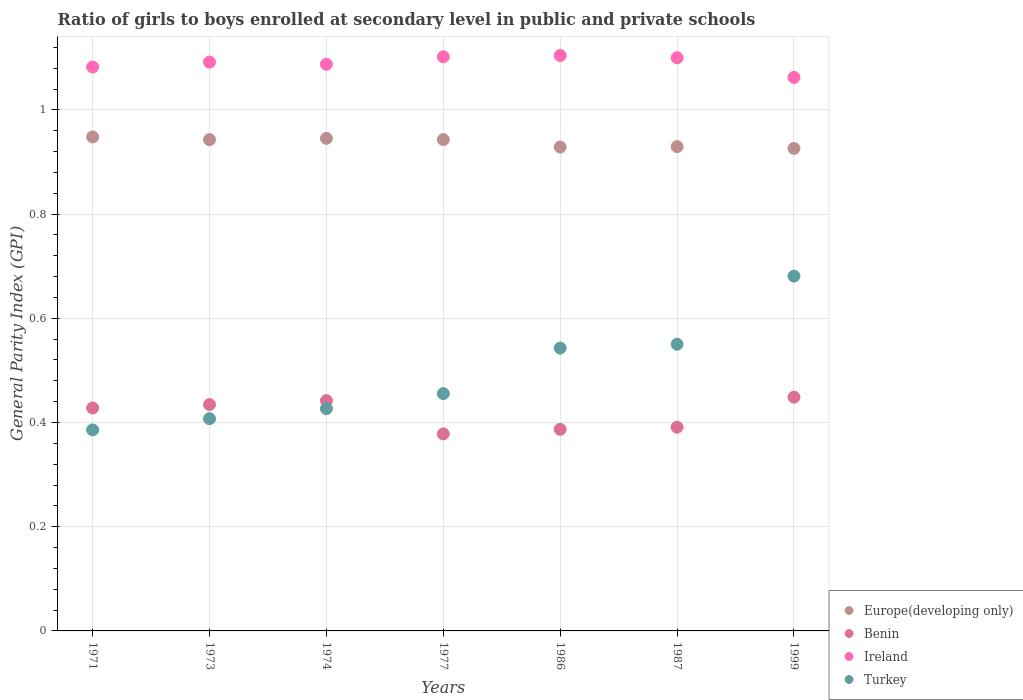How many different coloured dotlines are there?
Your response must be concise. 4. What is the general parity index in Ireland in 1986?
Offer a very short reply. 1.1. Across all years, what is the maximum general parity index in Ireland?
Offer a terse response. 1.1. Across all years, what is the minimum general parity index in Benin?
Ensure brevity in your answer.  0.38. In which year was the general parity index in Turkey minimum?
Your answer should be compact. 1971. What is the total general parity index in Turkey in the graph?
Your answer should be very brief. 3.45. What is the difference between the general parity index in Ireland in 1986 and that in 1999?
Provide a succinct answer. 0.04. What is the difference between the general parity index in Europe(developing only) in 1973 and the general parity index in Ireland in 1974?
Your answer should be compact. -0.14. What is the average general parity index in Benin per year?
Provide a short and direct response. 0.42. In the year 1999, what is the difference between the general parity index in Benin and general parity index in Ireland?
Make the answer very short. -0.61. What is the ratio of the general parity index in Ireland in 1977 to that in 1986?
Your answer should be compact. 1. Is the general parity index in Benin in 1971 less than that in 1973?
Your answer should be very brief. Yes. Is the difference between the general parity index in Benin in 1971 and 1986 greater than the difference between the general parity index in Ireland in 1971 and 1986?
Provide a short and direct response. Yes. What is the difference between the highest and the second highest general parity index in Turkey?
Your answer should be very brief. 0.13. What is the difference between the highest and the lowest general parity index in Europe(developing only)?
Ensure brevity in your answer.  0.02. In how many years, is the general parity index in Europe(developing only) greater than the average general parity index in Europe(developing only) taken over all years?
Your answer should be very brief. 4. Does the general parity index in Turkey monotonically increase over the years?
Give a very brief answer. Yes. Is the general parity index in Benin strictly greater than the general parity index in Ireland over the years?
Give a very brief answer. No. Is the general parity index in Turkey strictly less than the general parity index in Ireland over the years?
Give a very brief answer. Yes. How many dotlines are there?
Provide a short and direct response. 4. What is the difference between two consecutive major ticks on the Y-axis?
Offer a very short reply. 0.2. Does the graph contain grids?
Give a very brief answer. Yes. Where does the legend appear in the graph?
Your answer should be very brief. Bottom right. How many legend labels are there?
Ensure brevity in your answer.  4. What is the title of the graph?
Provide a succinct answer. Ratio of girls to boys enrolled at secondary level in public and private schools. Does "Greenland" appear as one of the legend labels in the graph?
Ensure brevity in your answer.  No. What is the label or title of the X-axis?
Provide a succinct answer. Years. What is the label or title of the Y-axis?
Your answer should be very brief. General Parity Index (GPI). What is the General Parity Index (GPI) of Europe(developing only) in 1971?
Your answer should be compact. 0.95. What is the General Parity Index (GPI) of Benin in 1971?
Make the answer very short. 0.43. What is the General Parity Index (GPI) in Ireland in 1971?
Your answer should be compact. 1.08. What is the General Parity Index (GPI) of Turkey in 1971?
Give a very brief answer. 0.39. What is the General Parity Index (GPI) of Europe(developing only) in 1973?
Provide a short and direct response. 0.94. What is the General Parity Index (GPI) in Benin in 1973?
Your response must be concise. 0.43. What is the General Parity Index (GPI) in Ireland in 1973?
Your response must be concise. 1.09. What is the General Parity Index (GPI) in Turkey in 1973?
Provide a short and direct response. 0.41. What is the General Parity Index (GPI) in Europe(developing only) in 1974?
Offer a terse response. 0.95. What is the General Parity Index (GPI) in Benin in 1974?
Provide a short and direct response. 0.44. What is the General Parity Index (GPI) in Ireland in 1974?
Provide a succinct answer. 1.09. What is the General Parity Index (GPI) in Turkey in 1974?
Keep it short and to the point. 0.43. What is the General Parity Index (GPI) in Europe(developing only) in 1977?
Provide a succinct answer. 0.94. What is the General Parity Index (GPI) in Benin in 1977?
Keep it short and to the point. 0.38. What is the General Parity Index (GPI) in Ireland in 1977?
Give a very brief answer. 1.1. What is the General Parity Index (GPI) of Turkey in 1977?
Provide a short and direct response. 0.46. What is the General Parity Index (GPI) of Europe(developing only) in 1986?
Make the answer very short. 0.93. What is the General Parity Index (GPI) of Benin in 1986?
Your answer should be compact. 0.39. What is the General Parity Index (GPI) of Ireland in 1986?
Keep it short and to the point. 1.1. What is the General Parity Index (GPI) in Turkey in 1986?
Provide a succinct answer. 0.54. What is the General Parity Index (GPI) of Europe(developing only) in 1987?
Provide a succinct answer. 0.93. What is the General Parity Index (GPI) in Benin in 1987?
Provide a succinct answer. 0.39. What is the General Parity Index (GPI) of Ireland in 1987?
Keep it short and to the point. 1.1. What is the General Parity Index (GPI) in Turkey in 1987?
Offer a terse response. 0.55. What is the General Parity Index (GPI) of Europe(developing only) in 1999?
Your answer should be compact. 0.93. What is the General Parity Index (GPI) in Benin in 1999?
Offer a very short reply. 0.45. What is the General Parity Index (GPI) in Ireland in 1999?
Provide a succinct answer. 1.06. What is the General Parity Index (GPI) in Turkey in 1999?
Offer a very short reply. 0.68. Across all years, what is the maximum General Parity Index (GPI) of Europe(developing only)?
Offer a terse response. 0.95. Across all years, what is the maximum General Parity Index (GPI) in Benin?
Offer a very short reply. 0.45. Across all years, what is the maximum General Parity Index (GPI) in Ireland?
Keep it short and to the point. 1.1. Across all years, what is the maximum General Parity Index (GPI) of Turkey?
Offer a very short reply. 0.68. Across all years, what is the minimum General Parity Index (GPI) of Europe(developing only)?
Your response must be concise. 0.93. Across all years, what is the minimum General Parity Index (GPI) of Benin?
Make the answer very short. 0.38. Across all years, what is the minimum General Parity Index (GPI) of Ireland?
Your response must be concise. 1.06. Across all years, what is the minimum General Parity Index (GPI) of Turkey?
Ensure brevity in your answer.  0.39. What is the total General Parity Index (GPI) in Europe(developing only) in the graph?
Keep it short and to the point. 6.56. What is the total General Parity Index (GPI) of Benin in the graph?
Make the answer very short. 2.91. What is the total General Parity Index (GPI) in Ireland in the graph?
Keep it short and to the point. 7.63. What is the total General Parity Index (GPI) of Turkey in the graph?
Ensure brevity in your answer.  3.45. What is the difference between the General Parity Index (GPI) in Europe(developing only) in 1971 and that in 1973?
Ensure brevity in your answer.  0.01. What is the difference between the General Parity Index (GPI) in Benin in 1971 and that in 1973?
Offer a terse response. -0.01. What is the difference between the General Parity Index (GPI) in Ireland in 1971 and that in 1973?
Your answer should be very brief. -0.01. What is the difference between the General Parity Index (GPI) in Turkey in 1971 and that in 1973?
Ensure brevity in your answer.  -0.02. What is the difference between the General Parity Index (GPI) of Europe(developing only) in 1971 and that in 1974?
Your response must be concise. 0. What is the difference between the General Parity Index (GPI) in Benin in 1971 and that in 1974?
Ensure brevity in your answer.  -0.01. What is the difference between the General Parity Index (GPI) of Ireland in 1971 and that in 1974?
Offer a terse response. -0.01. What is the difference between the General Parity Index (GPI) of Turkey in 1971 and that in 1974?
Ensure brevity in your answer.  -0.04. What is the difference between the General Parity Index (GPI) of Europe(developing only) in 1971 and that in 1977?
Offer a very short reply. 0.01. What is the difference between the General Parity Index (GPI) in Benin in 1971 and that in 1977?
Your answer should be very brief. 0.05. What is the difference between the General Parity Index (GPI) of Ireland in 1971 and that in 1977?
Ensure brevity in your answer.  -0.02. What is the difference between the General Parity Index (GPI) in Turkey in 1971 and that in 1977?
Provide a succinct answer. -0.07. What is the difference between the General Parity Index (GPI) of Europe(developing only) in 1971 and that in 1986?
Offer a terse response. 0.02. What is the difference between the General Parity Index (GPI) in Benin in 1971 and that in 1986?
Provide a short and direct response. 0.04. What is the difference between the General Parity Index (GPI) of Ireland in 1971 and that in 1986?
Provide a succinct answer. -0.02. What is the difference between the General Parity Index (GPI) in Turkey in 1971 and that in 1986?
Keep it short and to the point. -0.16. What is the difference between the General Parity Index (GPI) in Europe(developing only) in 1971 and that in 1987?
Your response must be concise. 0.02. What is the difference between the General Parity Index (GPI) of Benin in 1971 and that in 1987?
Give a very brief answer. 0.04. What is the difference between the General Parity Index (GPI) of Ireland in 1971 and that in 1987?
Make the answer very short. -0.02. What is the difference between the General Parity Index (GPI) of Turkey in 1971 and that in 1987?
Your response must be concise. -0.16. What is the difference between the General Parity Index (GPI) in Europe(developing only) in 1971 and that in 1999?
Your answer should be very brief. 0.02. What is the difference between the General Parity Index (GPI) of Benin in 1971 and that in 1999?
Offer a terse response. -0.02. What is the difference between the General Parity Index (GPI) in Ireland in 1971 and that in 1999?
Your answer should be very brief. 0.02. What is the difference between the General Parity Index (GPI) of Turkey in 1971 and that in 1999?
Your response must be concise. -0.3. What is the difference between the General Parity Index (GPI) in Europe(developing only) in 1973 and that in 1974?
Your response must be concise. -0. What is the difference between the General Parity Index (GPI) of Benin in 1973 and that in 1974?
Offer a terse response. -0.01. What is the difference between the General Parity Index (GPI) in Ireland in 1973 and that in 1974?
Provide a succinct answer. 0. What is the difference between the General Parity Index (GPI) in Turkey in 1973 and that in 1974?
Ensure brevity in your answer.  -0.02. What is the difference between the General Parity Index (GPI) in Europe(developing only) in 1973 and that in 1977?
Give a very brief answer. -0. What is the difference between the General Parity Index (GPI) in Benin in 1973 and that in 1977?
Provide a succinct answer. 0.06. What is the difference between the General Parity Index (GPI) in Ireland in 1973 and that in 1977?
Provide a succinct answer. -0.01. What is the difference between the General Parity Index (GPI) of Turkey in 1973 and that in 1977?
Offer a terse response. -0.05. What is the difference between the General Parity Index (GPI) of Europe(developing only) in 1973 and that in 1986?
Your answer should be compact. 0.01. What is the difference between the General Parity Index (GPI) of Benin in 1973 and that in 1986?
Your answer should be compact. 0.05. What is the difference between the General Parity Index (GPI) in Ireland in 1973 and that in 1986?
Your response must be concise. -0.01. What is the difference between the General Parity Index (GPI) in Turkey in 1973 and that in 1986?
Your response must be concise. -0.14. What is the difference between the General Parity Index (GPI) of Europe(developing only) in 1973 and that in 1987?
Ensure brevity in your answer.  0.01. What is the difference between the General Parity Index (GPI) of Benin in 1973 and that in 1987?
Make the answer very short. 0.04. What is the difference between the General Parity Index (GPI) of Ireland in 1973 and that in 1987?
Provide a short and direct response. -0.01. What is the difference between the General Parity Index (GPI) of Turkey in 1973 and that in 1987?
Offer a terse response. -0.14. What is the difference between the General Parity Index (GPI) of Europe(developing only) in 1973 and that in 1999?
Offer a terse response. 0.02. What is the difference between the General Parity Index (GPI) of Benin in 1973 and that in 1999?
Make the answer very short. -0.01. What is the difference between the General Parity Index (GPI) of Ireland in 1973 and that in 1999?
Make the answer very short. 0.03. What is the difference between the General Parity Index (GPI) in Turkey in 1973 and that in 1999?
Ensure brevity in your answer.  -0.27. What is the difference between the General Parity Index (GPI) of Europe(developing only) in 1974 and that in 1977?
Provide a short and direct response. 0. What is the difference between the General Parity Index (GPI) of Benin in 1974 and that in 1977?
Make the answer very short. 0.06. What is the difference between the General Parity Index (GPI) in Ireland in 1974 and that in 1977?
Offer a terse response. -0.01. What is the difference between the General Parity Index (GPI) in Turkey in 1974 and that in 1977?
Your answer should be compact. -0.03. What is the difference between the General Parity Index (GPI) in Europe(developing only) in 1974 and that in 1986?
Your answer should be compact. 0.02. What is the difference between the General Parity Index (GPI) of Benin in 1974 and that in 1986?
Your answer should be compact. 0.06. What is the difference between the General Parity Index (GPI) in Ireland in 1974 and that in 1986?
Your response must be concise. -0.02. What is the difference between the General Parity Index (GPI) of Turkey in 1974 and that in 1986?
Make the answer very short. -0.12. What is the difference between the General Parity Index (GPI) of Europe(developing only) in 1974 and that in 1987?
Your answer should be compact. 0.02. What is the difference between the General Parity Index (GPI) of Benin in 1974 and that in 1987?
Ensure brevity in your answer.  0.05. What is the difference between the General Parity Index (GPI) of Ireland in 1974 and that in 1987?
Ensure brevity in your answer.  -0.01. What is the difference between the General Parity Index (GPI) in Turkey in 1974 and that in 1987?
Offer a very short reply. -0.12. What is the difference between the General Parity Index (GPI) in Europe(developing only) in 1974 and that in 1999?
Offer a very short reply. 0.02. What is the difference between the General Parity Index (GPI) in Benin in 1974 and that in 1999?
Your answer should be compact. -0.01. What is the difference between the General Parity Index (GPI) in Ireland in 1974 and that in 1999?
Provide a succinct answer. 0.03. What is the difference between the General Parity Index (GPI) in Turkey in 1974 and that in 1999?
Provide a short and direct response. -0.25. What is the difference between the General Parity Index (GPI) in Europe(developing only) in 1977 and that in 1986?
Offer a terse response. 0.01. What is the difference between the General Parity Index (GPI) in Benin in 1977 and that in 1986?
Offer a very short reply. -0.01. What is the difference between the General Parity Index (GPI) in Ireland in 1977 and that in 1986?
Provide a succinct answer. -0. What is the difference between the General Parity Index (GPI) in Turkey in 1977 and that in 1986?
Keep it short and to the point. -0.09. What is the difference between the General Parity Index (GPI) of Europe(developing only) in 1977 and that in 1987?
Your response must be concise. 0.01. What is the difference between the General Parity Index (GPI) in Benin in 1977 and that in 1987?
Your response must be concise. -0.01. What is the difference between the General Parity Index (GPI) of Ireland in 1977 and that in 1987?
Your answer should be very brief. 0. What is the difference between the General Parity Index (GPI) of Turkey in 1977 and that in 1987?
Your answer should be compact. -0.09. What is the difference between the General Parity Index (GPI) of Europe(developing only) in 1977 and that in 1999?
Your answer should be compact. 0.02. What is the difference between the General Parity Index (GPI) of Benin in 1977 and that in 1999?
Ensure brevity in your answer.  -0.07. What is the difference between the General Parity Index (GPI) of Ireland in 1977 and that in 1999?
Keep it short and to the point. 0.04. What is the difference between the General Parity Index (GPI) of Turkey in 1977 and that in 1999?
Make the answer very short. -0.23. What is the difference between the General Parity Index (GPI) in Europe(developing only) in 1986 and that in 1987?
Provide a short and direct response. -0. What is the difference between the General Parity Index (GPI) in Benin in 1986 and that in 1987?
Offer a terse response. -0. What is the difference between the General Parity Index (GPI) of Ireland in 1986 and that in 1987?
Offer a terse response. 0. What is the difference between the General Parity Index (GPI) of Turkey in 1986 and that in 1987?
Give a very brief answer. -0.01. What is the difference between the General Parity Index (GPI) in Europe(developing only) in 1986 and that in 1999?
Provide a short and direct response. 0. What is the difference between the General Parity Index (GPI) in Benin in 1986 and that in 1999?
Make the answer very short. -0.06. What is the difference between the General Parity Index (GPI) of Ireland in 1986 and that in 1999?
Your response must be concise. 0.04. What is the difference between the General Parity Index (GPI) of Turkey in 1986 and that in 1999?
Ensure brevity in your answer.  -0.14. What is the difference between the General Parity Index (GPI) in Europe(developing only) in 1987 and that in 1999?
Make the answer very short. 0. What is the difference between the General Parity Index (GPI) of Benin in 1987 and that in 1999?
Keep it short and to the point. -0.06. What is the difference between the General Parity Index (GPI) of Ireland in 1987 and that in 1999?
Offer a very short reply. 0.04. What is the difference between the General Parity Index (GPI) of Turkey in 1987 and that in 1999?
Ensure brevity in your answer.  -0.13. What is the difference between the General Parity Index (GPI) in Europe(developing only) in 1971 and the General Parity Index (GPI) in Benin in 1973?
Your answer should be compact. 0.51. What is the difference between the General Parity Index (GPI) in Europe(developing only) in 1971 and the General Parity Index (GPI) in Ireland in 1973?
Ensure brevity in your answer.  -0.14. What is the difference between the General Parity Index (GPI) of Europe(developing only) in 1971 and the General Parity Index (GPI) of Turkey in 1973?
Your response must be concise. 0.54. What is the difference between the General Parity Index (GPI) in Benin in 1971 and the General Parity Index (GPI) in Ireland in 1973?
Offer a very short reply. -0.66. What is the difference between the General Parity Index (GPI) in Benin in 1971 and the General Parity Index (GPI) in Turkey in 1973?
Your answer should be compact. 0.02. What is the difference between the General Parity Index (GPI) in Ireland in 1971 and the General Parity Index (GPI) in Turkey in 1973?
Offer a terse response. 0.67. What is the difference between the General Parity Index (GPI) of Europe(developing only) in 1971 and the General Parity Index (GPI) of Benin in 1974?
Give a very brief answer. 0.51. What is the difference between the General Parity Index (GPI) of Europe(developing only) in 1971 and the General Parity Index (GPI) of Ireland in 1974?
Keep it short and to the point. -0.14. What is the difference between the General Parity Index (GPI) in Europe(developing only) in 1971 and the General Parity Index (GPI) in Turkey in 1974?
Provide a succinct answer. 0.52. What is the difference between the General Parity Index (GPI) of Benin in 1971 and the General Parity Index (GPI) of Ireland in 1974?
Ensure brevity in your answer.  -0.66. What is the difference between the General Parity Index (GPI) of Benin in 1971 and the General Parity Index (GPI) of Turkey in 1974?
Your answer should be compact. 0. What is the difference between the General Parity Index (GPI) of Ireland in 1971 and the General Parity Index (GPI) of Turkey in 1974?
Offer a terse response. 0.66. What is the difference between the General Parity Index (GPI) in Europe(developing only) in 1971 and the General Parity Index (GPI) in Benin in 1977?
Give a very brief answer. 0.57. What is the difference between the General Parity Index (GPI) in Europe(developing only) in 1971 and the General Parity Index (GPI) in Ireland in 1977?
Provide a succinct answer. -0.15. What is the difference between the General Parity Index (GPI) of Europe(developing only) in 1971 and the General Parity Index (GPI) of Turkey in 1977?
Provide a short and direct response. 0.49. What is the difference between the General Parity Index (GPI) of Benin in 1971 and the General Parity Index (GPI) of Ireland in 1977?
Your answer should be compact. -0.67. What is the difference between the General Parity Index (GPI) of Benin in 1971 and the General Parity Index (GPI) of Turkey in 1977?
Provide a short and direct response. -0.03. What is the difference between the General Parity Index (GPI) of Ireland in 1971 and the General Parity Index (GPI) of Turkey in 1977?
Provide a short and direct response. 0.63. What is the difference between the General Parity Index (GPI) in Europe(developing only) in 1971 and the General Parity Index (GPI) in Benin in 1986?
Provide a succinct answer. 0.56. What is the difference between the General Parity Index (GPI) of Europe(developing only) in 1971 and the General Parity Index (GPI) of Ireland in 1986?
Keep it short and to the point. -0.16. What is the difference between the General Parity Index (GPI) in Europe(developing only) in 1971 and the General Parity Index (GPI) in Turkey in 1986?
Provide a short and direct response. 0.41. What is the difference between the General Parity Index (GPI) of Benin in 1971 and the General Parity Index (GPI) of Ireland in 1986?
Make the answer very short. -0.68. What is the difference between the General Parity Index (GPI) of Benin in 1971 and the General Parity Index (GPI) of Turkey in 1986?
Provide a succinct answer. -0.11. What is the difference between the General Parity Index (GPI) in Ireland in 1971 and the General Parity Index (GPI) in Turkey in 1986?
Ensure brevity in your answer.  0.54. What is the difference between the General Parity Index (GPI) of Europe(developing only) in 1971 and the General Parity Index (GPI) of Benin in 1987?
Provide a short and direct response. 0.56. What is the difference between the General Parity Index (GPI) of Europe(developing only) in 1971 and the General Parity Index (GPI) of Ireland in 1987?
Provide a short and direct response. -0.15. What is the difference between the General Parity Index (GPI) of Europe(developing only) in 1971 and the General Parity Index (GPI) of Turkey in 1987?
Give a very brief answer. 0.4. What is the difference between the General Parity Index (GPI) of Benin in 1971 and the General Parity Index (GPI) of Ireland in 1987?
Your response must be concise. -0.67. What is the difference between the General Parity Index (GPI) in Benin in 1971 and the General Parity Index (GPI) in Turkey in 1987?
Ensure brevity in your answer.  -0.12. What is the difference between the General Parity Index (GPI) in Ireland in 1971 and the General Parity Index (GPI) in Turkey in 1987?
Ensure brevity in your answer.  0.53. What is the difference between the General Parity Index (GPI) in Europe(developing only) in 1971 and the General Parity Index (GPI) in Benin in 1999?
Offer a very short reply. 0.5. What is the difference between the General Parity Index (GPI) in Europe(developing only) in 1971 and the General Parity Index (GPI) in Ireland in 1999?
Offer a very short reply. -0.11. What is the difference between the General Parity Index (GPI) of Europe(developing only) in 1971 and the General Parity Index (GPI) of Turkey in 1999?
Give a very brief answer. 0.27. What is the difference between the General Parity Index (GPI) of Benin in 1971 and the General Parity Index (GPI) of Ireland in 1999?
Ensure brevity in your answer.  -0.63. What is the difference between the General Parity Index (GPI) in Benin in 1971 and the General Parity Index (GPI) in Turkey in 1999?
Your response must be concise. -0.25. What is the difference between the General Parity Index (GPI) of Ireland in 1971 and the General Parity Index (GPI) of Turkey in 1999?
Keep it short and to the point. 0.4. What is the difference between the General Parity Index (GPI) of Europe(developing only) in 1973 and the General Parity Index (GPI) of Benin in 1974?
Your response must be concise. 0.5. What is the difference between the General Parity Index (GPI) in Europe(developing only) in 1973 and the General Parity Index (GPI) in Ireland in 1974?
Ensure brevity in your answer.  -0.14. What is the difference between the General Parity Index (GPI) in Europe(developing only) in 1973 and the General Parity Index (GPI) in Turkey in 1974?
Your answer should be compact. 0.52. What is the difference between the General Parity Index (GPI) of Benin in 1973 and the General Parity Index (GPI) of Ireland in 1974?
Provide a short and direct response. -0.65. What is the difference between the General Parity Index (GPI) in Benin in 1973 and the General Parity Index (GPI) in Turkey in 1974?
Offer a very short reply. 0.01. What is the difference between the General Parity Index (GPI) of Ireland in 1973 and the General Parity Index (GPI) of Turkey in 1974?
Your response must be concise. 0.67. What is the difference between the General Parity Index (GPI) in Europe(developing only) in 1973 and the General Parity Index (GPI) in Benin in 1977?
Ensure brevity in your answer.  0.56. What is the difference between the General Parity Index (GPI) of Europe(developing only) in 1973 and the General Parity Index (GPI) of Ireland in 1977?
Offer a terse response. -0.16. What is the difference between the General Parity Index (GPI) of Europe(developing only) in 1973 and the General Parity Index (GPI) of Turkey in 1977?
Give a very brief answer. 0.49. What is the difference between the General Parity Index (GPI) of Benin in 1973 and the General Parity Index (GPI) of Ireland in 1977?
Keep it short and to the point. -0.67. What is the difference between the General Parity Index (GPI) of Benin in 1973 and the General Parity Index (GPI) of Turkey in 1977?
Your response must be concise. -0.02. What is the difference between the General Parity Index (GPI) in Ireland in 1973 and the General Parity Index (GPI) in Turkey in 1977?
Give a very brief answer. 0.64. What is the difference between the General Parity Index (GPI) in Europe(developing only) in 1973 and the General Parity Index (GPI) in Benin in 1986?
Ensure brevity in your answer.  0.56. What is the difference between the General Parity Index (GPI) of Europe(developing only) in 1973 and the General Parity Index (GPI) of Ireland in 1986?
Your answer should be compact. -0.16. What is the difference between the General Parity Index (GPI) in Europe(developing only) in 1973 and the General Parity Index (GPI) in Turkey in 1986?
Keep it short and to the point. 0.4. What is the difference between the General Parity Index (GPI) in Benin in 1973 and the General Parity Index (GPI) in Ireland in 1986?
Offer a terse response. -0.67. What is the difference between the General Parity Index (GPI) of Benin in 1973 and the General Parity Index (GPI) of Turkey in 1986?
Ensure brevity in your answer.  -0.11. What is the difference between the General Parity Index (GPI) of Ireland in 1973 and the General Parity Index (GPI) of Turkey in 1986?
Make the answer very short. 0.55. What is the difference between the General Parity Index (GPI) of Europe(developing only) in 1973 and the General Parity Index (GPI) of Benin in 1987?
Keep it short and to the point. 0.55. What is the difference between the General Parity Index (GPI) in Europe(developing only) in 1973 and the General Parity Index (GPI) in Ireland in 1987?
Offer a terse response. -0.16. What is the difference between the General Parity Index (GPI) in Europe(developing only) in 1973 and the General Parity Index (GPI) in Turkey in 1987?
Ensure brevity in your answer.  0.39. What is the difference between the General Parity Index (GPI) of Benin in 1973 and the General Parity Index (GPI) of Ireland in 1987?
Provide a short and direct response. -0.67. What is the difference between the General Parity Index (GPI) of Benin in 1973 and the General Parity Index (GPI) of Turkey in 1987?
Provide a short and direct response. -0.12. What is the difference between the General Parity Index (GPI) in Ireland in 1973 and the General Parity Index (GPI) in Turkey in 1987?
Provide a short and direct response. 0.54. What is the difference between the General Parity Index (GPI) in Europe(developing only) in 1973 and the General Parity Index (GPI) in Benin in 1999?
Your response must be concise. 0.49. What is the difference between the General Parity Index (GPI) in Europe(developing only) in 1973 and the General Parity Index (GPI) in Ireland in 1999?
Your response must be concise. -0.12. What is the difference between the General Parity Index (GPI) in Europe(developing only) in 1973 and the General Parity Index (GPI) in Turkey in 1999?
Make the answer very short. 0.26. What is the difference between the General Parity Index (GPI) in Benin in 1973 and the General Parity Index (GPI) in Ireland in 1999?
Your response must be concise. -0.63. What is the difference between the General Parity Index (GPI) of Benin in 1973 and the General Parity Index (GPI) of Turkey in 1999?
Your answer should be very brief. -0.25. What is the difference between the General Parity Index (GPI) in Ireland in 1973 and the General Parity Index (GPI) in Turkey in 1999?
Offer a terse response. 0.41. What is the difference between the General Parity Index (GPI) of Europe(developing only) in 1974 and the General Parity Index (GPI) of Benin in 1977?
Offer a very short reply. 0.57. What is the difference between the General Parity Index (GPI) of Europe(developing only) in 1974 and the General Parity Index (GPI) of Ireland in 1977?
Provide a short and direct response. -0.16. What is the difference between the General Parity Index (GPI) in Europe(developing only) in 1974 and the General Parity Index (GPI) in Turkey in 1977?
Give a very brief answer. 0.49. What is the difference between the General Parity Index (GPI) of Benin in 1974 and the General Parity Index (GPI) of Ireland in 1977?
Provide a succinct answer. -0.66. What is the difference between the General Parity Index (GPI) of Benin in 1974 and the General Parity Index (GPI) of Turkey in 1977?
Ensure brevity in your answer.  -0.01. What is the difference between the General Parity Index (GPI) of Ireland in 1974 and the General Parity Index (GPI) of Turkey in 1977?
Offer a very short reply. 0.63. What is the difference between the General Parity Index (GPI) of Europe(developing only) in 1974 and the General Parity Index (GPI) of Benin in 1986?
Offer a terse response. 0.56. What is the difference between the General Parity Index (GPI) in Europe(developing only) in 1974 and the General Parity Index (GPI) in Ireland in 1986?
Ensure brevity in your answer.  -0.16. What is the difference between the General Parity Index (GPI) in Europe(developing only) in 1974 and the General Parity Index (GPI) in Turkey in 1986?
Provide a succinct answer. 0.4. What is the difference between the General Parity Index (GPI) of Benin in 1974 and the General Parity Index (GPI) of Ireland in 1986?
Provide a succinct answer. -0.66. What is the difference between the General Parity Index (GPI) of Benin in 1974 and the General Parity Index (GPI) of Turkey in 1986?
Ensure brevity in your answer.  -0.1. What is the difference between the General Parity Index (GPI) of Ireland in 1974 and the General Parity Index (GPI) of Turkey in 1986?
Make the answer very short. 0.54. What is the difference between the General Parity Index (GPI) of Europe(developing only) in 1974 and the General Parity Index (GPI) of Benin in 1987?
Your answer should be compact. 0.55. What is the difference between the General Parity Index (GPI) in Europe(developing only) in 1974 and the General Parity Index (GPI) in Ireland in 1987?
Give a very brief answer. -0.15. What is the difference between the General Parity Index (GPI) in Europe(developing only) in 1974 and the General Parity Index (GPI) in Turkey in 1987?
Provide a short and direct response. 0.4. What is the difference between the General Parity Index (GPI) in Benin in 1974 and the General Parity Index (GPI) in Ireland in 1987?
Your answer should be very brief. -0.66. What is the difference between the General Parity Index (GPI) of Benin in 1974 and the General Parity Index (GPI) of Turkey in 1987?
Give a very brief answer. -0.11. What is the difference between the General Parity Index (GPI) of Ireland in 1974 and the General Parity Index (GPI) of Turkey in 1987?
Your response must be concise. 0.54. What is the difference between the General Parity Index (GPI) in Europe(developing only) in 1974 and the General Parity Index (GPI) in Benin in 1999?
Make the answer very short. 0.5. What is the difference between the General Parity Index (GPI) in Europe(developing only) in 1974 and the General Parity Index (GPI) in Ireland in 1999?
Your answer should be compact. -0.12. What is the difference between the General Parity Index (GPI) of Europe(developing only) in 1974 and the General Parity Index (GPI) of Turkey in 1999?
Your answer should be very brief. 0.26. What is the difference between the General Parity Index (GPI) in Benin in 1974 and the General Parity Index (GPI) in Ireland in 1999?
Offer a terse response. -0.62. What is the difference between the General Parity Index (GPI) of Benin in 1974 and the General Parity Index (GPI) of Turkey in 1999?
Keep it short and to the point. -0.24. What is the difference between the General Parity Index (GPI) in Ireland in 1974 and the General Parity Index (GPI) in Turkey in 1999?
Provide a short and direct response. 0.41. What is the difference between the General Parity Index (GPI) of Europe(developing only) in 1977 and the General Parity Index (GPI) of Benin in 1986?
Provide a succinct answer. 0.56. What is the difference between the General Parity Index (GPI) of Europe(developing only) in 1977 and the General Parity Index (GPI) of Ireland in 1986?
Your answer should be compact. -0.16. What is the difference between the General Parity Index (GPI) of Europe(developing only) in 1977 and the General Parity Index (GPI) of Turkey in 1986?
Your response must be concise. 0.4. What is the difference between the General Parity Index (GPI) of Benin in 1977 and the General Parity Index (GPI) of Ireland in 1986?
Provide a succinct answer. -0.73. What is the difference between the General Parity Index (GPI) in Benin in 1977 and the General Parity Index (GPI) in Turkey in 1986?
Your answer should be very brief. -0.16. What is the difference between the General Parity Index (GPI) of Ireland in 1977 and the General Parity Index (GPI) of Turkey in 1986?
Your answer should be compact. 0.56. What is the difference between the General Parity Index (GPI) in Europe(developing only) in 1977 and the General Parity Index (GPI) in Benin in 1987?
Your response must be concise. 0.55. What is the difference between the General Parity Index (GPI) of Europe(developing only) in 1977 and the General Parity Index (GPI) of Ireland in 1987?
Offer a very short reply. -0.16. What is the difference between the General Parity Index (GPI) in Europe(developing only) in 1977 and the General Parity Index (GPI) in Turkey in 1987?
Your answer should be compact. 0.39. What is the difference between the General Parity Index (GPI) of Benin in 1977 and the General Parity Index (GPI) of Ireland in 1987?
Offer a terse response. -0.72. What is the difference between the General Parity Index (GPI) of Benin in 1977 and the General Parity Index (GPI) of Turkey in 1987?
Make the answer very short. -0.17. What is the difference between the General Parity Index (GPI) in Ireland in 1977 and the General Parity Index (GPI) in Turkey in 1987?
Offer a very short reply. 0.55. What is the difference between the General Parity Index (GPI) of Europe(developing only) in 1977 and the General Parity Index (GPI) of Benin in 1999?
Your answer should be compact. 0.49. What is the difference between the General Parity Index (GPI) in Europe(developing only) in 1977 and the General Parity Index (GPI) in Ireland in 1999?
Your answer should be compact. -0.12. What is the difference between the General Parity Index (GPI) of Europe(developing only) in 1977 and the General Parity Index (GPI) of Turkey in 1999?
Your answer should be compact. 0.26. What is the difference between the General Parity Index (GPI) in Benin in 1977 and the General Parity Index (GPI) in Ireland in 1999?
Your answer should be compact. -0.68. What is the difference between the General Parity Index (GPI) of Benin in 1977 and the General Parity Index (GPI) of Turkey in 1999?
Offer a very short reply. -0.3. What is the difference between the General Parity Index (GPI) in Ireland in 1977 and the General Parity Index (GPI) in Turkey in 1999?
Offer a very short reply. 0.42. What is the difference between the General Parity Index (GPI) in Europe(developing only) in 1986 and the General Parity Index (GPI) in Benin in 1987?
Your response must be concise. 0.54. What is the difference between the General Parity Index (GPI) in Europe(developing only) in 1986 and the General Parity Index (GPI) in Ireland in 1987?
Give a very brief answer. -0.17. What is the difference between the General Parity Index (GPI) of Europe(developing only) in 1986 and the General Parity Index (GPI) of Turkey in 1987?
Offer a terse response. 0.38. What is the difference between the General Parity Index (GPI) of Benin in 1986 and the General Parity Index (GPI) of Ireland in 1987?
Offer a very short reply. -0.71. What is the difference between the General Parity Index (GPI) in Benin in 1986 and the General Parity Index (GPI) in Turkey in 1987?
Offer a very short reply. -0.16. What is the difference between the General Parity Index (GPI) in Ireland in 1986 and the General Parity Index (GPI) in Turkey in 1987?
Your answer should be very brief. 0.55. What is the difference between the General Parity Index (GPI) of Europe(developing only) in 1986 and the General Parity Index (GPI) of Benin in 1999?
Provide a short and direct response. 0.48. What is the difference between the General Parity Index (GPI) in Europe(developing only) in 1986 and the General Parity Index (GPI) in Ireland in 1999?
Your response must be concise. -0.13. What is the difference between the General Parity Index (GPI) in Europe(developing only) in 1986 and the General Parity Index (GPI) in Turkey in 1999?
Your answer should be very brief. 0.25. What is the difference between the General Parity Index (GPI) of Benin in 1986 and the General Parity Index (GPI) of Ireland in 1999?
Your answer should be compact. -0.68. What is the difference between the General Parity Index (GPI) in Benin in 1986 and the General Parity Index (GPI) in Turkey in 1999?
Give a very brief answer. -0.29. What is the difference between the General Parity Index (GPI) in Ireland in 1986 and the General Parity Index (GPI) in Turkey in 1999?
Provide a succinct answer. 0.42. What is the difference between the General Parity Index (GPI) in Europe(developing only) in 1987 and the General Parity Index (GPI) in Benin in 1999?
Offer a terse response. 0.48. What is the difference between the General Parity Index (GPI) of Europe(developing only) in 1987 and the General Parity Index (GPI) of Ireland in 1999?
Ensure brevity in your answer.  -0.13. What is the difference between the General Parity Index (GPI) of Europe(developing only) in 1987 and the General Parity Index (GPI) of Turkey in 1999?
Your answer should be compact. 0.25. What is the difference between the General Parity Index (GPI) in Benin in 1987 and the General Parity Index (GPI) in Ireland in 1999?
Keep it short and to the point. -0.67. What is the difference between the General Parity Index (GPI) of Benin in 1987 and the General Parity Index (GPI) of Turkey in 1999?
Your response must be concise. -0.29. What is the difference between the General Parity Index (GPI) of Ireland in 1987 and the General Parity Index (GPI) of Turkey in 1999?
Give a very brief answer. 0.42. What is the average General Parity Index (GPI) of Europe(developing only) per year?
Make the answer very short. 0.94. What is the average General Parity Index (GPI) of Benin per year?
Offer a terse response. 0.42. What is the average General Parity Index (GPI) in Ireland per year?
Provide a short and direct response. 1.09. What is the average General Parity Index (GPI) of Turkey per year?
Offer a very short reply. 0.49. In the year 1971, what is the difference between the General Parity Index (GPI) in Europe(developing only) and General Parity Index (GPI) in Benin?
Your answer should be compact. 0.52. In the year 1971, what is the difference between the General Parity Index (GPI) of Europe(developing only) and General Parity Index (GPI) of Ireland?
Provide a succinct answer. -0.13. In the year 1971, what is the difference between the General Parity Index (GPI) of Europe(developing only) and General Parity Index (GPI) of Turkey?
Provide a succinct answer. 0.56. In the year 1971, what is the difference between the General Parity Index (GPI) in Benin and General Parity Index (GPI) in Ireland?
Your answer should be very brief. -0.65. In the year 1971, what is the difference between the General Parity Index (GPI) of Benin and General Parity Index (GPI) of Turkey?
Ensure brevity in your answer.  0.04. In the year 1971, what is the difference between the General Parity Index (GPI) in Ireland and General Parity Index (GPI) in Turkey?
Offer a terse response. 0.7. In the year 1973, what is the difference between the General Parity Index (GPI) of Europe(developing only) and General Parity Index (GPI) of Benin?
Your answer should be compact. 0.51. In the year 1973, what is the difference between the General Parity Index (GPI) of Europe(developing only) and General Parity Index (GPI) of Ireland?
Give a very brief answer. -0.15. In the year 1973, what is the difference between the General Parity Index (GPI) of Europe(developing only) and General Parity Index (GPI) of Turkey?
Your answer should be compact. 0.54. In the year 1973, what is the difference between the General Parity Index (GPI) in Benin and General Parity Index (GPI) in Ireland?
Provide a short and direct response. -0.66. In the year 1973, what is the difference between the General Parity Index (GPI) of Benin and General Parity Index (GPI) of Turkey?
Your answer should be compact. 0.03. In the year 1973, what is the difference between the General Parity Index (GPI) of Ireland and General Parity Index (GPI) of Turkey?
Your answer should be compact. 0.68. In the year 1974, what is the difference between the General Parity Index (GPI) in Europe(developing only) and General Parity Index (GPI) in Benin?
Give a very brief answer. 0.5. In the year 1974, what is the difference between the General Parity Index (GPI) in Europe(developing only) and General Parity Index (GPI) in Ireland?
Offer a very short reply. -0.14. In the year 1974, what is the difference between the General Parity Index (GPI) in Europe(developing only) and General Parity Index (GPI) in Turkey?
Provide a short and direct response. 0.52. In the year 1974, what is the difference between the General Parity Index (GPI) of Benin and General Parity Index (GPI) of Ireland?
Keep it short and to the point. -0.65. In the year 1974, what is the difference between the General Parity Index (GPI) of Benin and General Parity Index (GPI) of Turkey?
Provide a short and direct response. 0.02. In the year 1974, what is the difference between the General Parity Index (GPI) of Ireland and General Parity Index (GPI) of Turkey?
Offer a terse response. 0.66. In the year 1977, what is the difference between the General Parity Index (GPI) of Europe(developing only) and General Parity Index (GPI) of Benin?
Make the answer very short. 0.56. In the year 1977, what is the difference between the General Parity Index (GPI) of Europe(developing only) and General Parity Index (GPI) of Ireland?
Offer a terse response. -0.16. In the year 1977, what is the difference between the General Parity Index (GPI) of Europe(developing only) and General Parity Index (GPI) of Turkey?
Ensure brevity in your answer.  0.49. In the year 1977, what is the difference between the General Parity Index (GPI) in Benin and General Parity Index (GPI) in Ireland?
Offer a terse response. -0.72. In the year 1977, what is the difference between the General Parity Index (GPI) of Benin and General Parity Index (GPI) of Turkey?
Ensure brevity in your answer.  -0.08. In the year 1977, what is the difference between the General Parity Index (GPI) of Ireland and General Parity Index (GPI) of Turkey?
Ensure brevity in your answer.  0.65. In the year 1986, what is the difference between the General Parity Index (GPI) in Europe(developing only) and General Parity Index (GPI) in Benin?
Your answer should be compact. 0.54. In the year 1986, what is the difference between the General Parity Index (GPI) of Europe(developing only) and General Parity Index (GPI) of Ireland?
Keep it short and to the point. -0.18. In the year 1986, what is the difference between the General Parity Index (GPI) of Europe(developing only) and General Parity Index (GPI) of Turkey?
Your answer should be compact. 0.39. In the year 1986, what is the difference between the General Parity Index (GPI) of Benin and General Parity Index (GPI) of Ireland?
Give a very brief answer. -0.72. In the year 1986, what is the difference between the General Parity Index (GPI) in Benin and General Parity Index (GPI) in Turkey?
Ensure brevity in your answer.  -0.16. In the year 1986, what is the difference between the General Parity Index (GPI) in Ireland and General Parity Index (GPI) in Turkey?
Provide a succinct answer. 0.56. In the year 1987, what is the difference between the General Parity Index (GPI) of Europe(developing only) and General Parity Index (GPI) of Benin?
Make the answer very short. 0.54. In the year 1987, what is the difference between the General Parity Index (GPI) of Europe(developing only) and General Parity Index (GPI) of Ireland?
Your answer should be compact. -0.17. In the year 1987, what is the difference between the General Parity Index (GPI) in Europe(developing only) and General Parity Index (GPI) in Turkey?
Provide a short and direct response. 0.38. In the year 1987, what is the difference between the General Parity Index (GPI) in Benin and General Parity Index (GPI) in Ireland?
Your answer should be compact. -0.71. In the year 1987, what is the difference between the General Parity Index (GPI) in Benin and General Parity Index (GPI) in Turkey?
Offer a very short reply. -0.16. In the year 1987, what is the difference between the General Parity Index (GPI) in Ireland and General Parity Index (GPI) in Turkey?
Provide a succinct answer. 0.55. In the year 1999, what is the difference between the General Parity Index (GPI) of Europe(developing only) and General Parity Index (GPI) of Benin?
Provide a succinct answer. 0.48. In the year 1999, what is the difference between the General Parity Index (GPI) of Europe(developing only) and General Parity Index (GPI) of Ireland?
Ensure brevity in your answer.  -0.14. In the year 1999, what is the difference between the General Parity Index (GPI) in Europe(developing only) and General Parity Index (GPI) in Turkey?
Provide a short and direct response. 0.25. In the year 1999, what is the difference between the General Parity Index (GPI) in Benin and General Parity Index (GPI) in Ireland?
Give a very brief answer. -0.61. In the year 1999, what is the difference between the General Parity Index (GPI) of Benin and General Parity Index (GPI) of Turkey?
Your answer should be compact. -0.23. In the year 1999, what is the difference between the General Parity Index (GPI) in Ireland and General Parity Index (GPI) in Turkey?
Give a very brief answer. 0.38. What is the ratio of the General Parity Index (GPI) of Europe(developing only) in 1971 to that in 1973?
Ensure brevity in your answer.  1.01. What is the ratio of the General Parity Index (GPI) of Benin in 1971 to that in 1973?
Offer a terse response. 0.98. What is the ratio of the General Parity Index (GPI) of Ireland in 1971 to that in 1973?
Your answer should be very brief. 0.99. What is the ratio of the General Parity Index (GPI) of Turkey in 1971 to that in 1973?
Give a very brief answer. 0.95. What is the ratio of the General Parity Index (GPI) in Europe(developing only) in 1971 to that in 1974?
Ensure brevity in your answer.  1. What is the ratio of the General Parity Index (GPI) of Benin in 1971 to that in 1974?
Give a very brief answer. 0.97. What is the ratio of the General Parity Index (GPI) in Turkey in 1971 to that in 1974?
Provide a succinct answer. 0.9. What is the ratio of the General Parity Index (GPI) in Europe(developing only) in 1971 to that in 1977?
Provide a succinct answer. 1.01. What is the ratio of the General Parity Index (GPI) of Benin in 1971 to that in 1977?
Ensure brevity in your answer.  1.13. What is the ratio of the General Parity Index (GPI) in Ireland in 1971 to that in 1977?
Provide a succinct answer. 0.98. What is the ratio of the General Parity Index (GPI) in Turkey in 1971 to that in 1977?
Offer a terse response. 0.85. What is the ratio of the General Parity Index (GPI) of Europe(developing only) in 1971 to that in 1986?
Offer a very short reply. 1.02. What is the ratio of the General Parity Index (GPI) of Benin in 1971 to that in 1986?
Keep it short and to the point. 1.11. What is the ratio of the General Parity Index (GPI) in Ireland in 1971 to that in 1986?
Make the answer very short. 0.98. What is the ratio of the General Parity Index (GPI) in Turkey in 1971 to that in 1986?
Your answer should be very brief. 0.71. What is the ratio of the General Parity Index (GPI) of Europe(developing only) in 1971 to that in 1987?
Your response must be concise. 1.02. What is the ratio of the General Parity Index (GPI) of Benin in 1971 to that in 1987?
Your answer should be very brief. 1.09. What is the ratio of the General Parity Index (GPI) of Ireland in 1971 to that in 1987?
Give a very brief answer. 0.98. What is the ratio of the General Parity Index (GPI) in Turkey in 1971 to that in 1987?
Your response must be concise. 0.7. What is the ratio of the General Parity Index (GPI) in Europe(developing only) in 1971 to that in 1999?
Provide a succinct answer. 1.02. What is the ratio of the General Parity Index (GPI) in Benin in 1971 to that in 1999?
Your answer should be very brief. 0.95. What is the ratio of the General Parity Index (GPI) of Ireland in 1971 to that in 1999?
Your answer should be compact. 1.02. What is the ratio of the General Parity Index (GPI) in Turkey in 1971 to that in 1999?
Make the answer very short. 0.57. What is the ratio of the General Parity Index (GPI) in Europe(developing only) in 1973 to that in 1974?
Your answer should be very brief. 1. What is the ratio of the General Parity Index (GPI) in Benin in 1973 to that in 1974?
Your answer should be very brief. 0.98. What is the ratio of the General Parity Index (GPI) in Ireland in 1973 to that in 1974?
Give a very brief answer. 1. What is the ratio of the General Parity Index (GPI) in Turkey in 1973 to that in 1974?
Give a very brief answer. 0.95. What is the ratio of the General Parity Index (GPI) of Europe(developing only) in 1973 to that in 1977?
Provide a succinct answer. 1. What is the ratio of the General Parity Index (GPI) in Benin in 1973 to that in 1977?
Your answer should be very brief. 1.15. What is the ratio of the General Parity Index (GPI) of Ireland in 1973 to that in 1977?
Keep it short and to the point. 0.99. What is the ratio of the General Parity Index (GPI) of Turkey in 1973 to that in 1977?
Offer a very short reply. 0.89. What is the ratio of the General Parity Index (GPI) of Europe(developing only) in 1973 to that in 1986?
Your answer should be compact. 1.02. What is the ratio of the General Parity Index (GPI) in Benin in 1973 to that in 1986?
Your answer should be compact. 1.12. What is the ratio of the General Parity Index (GPI) in Ireland in 1973 to that in 1986?
Offer a terse response. 0.99. What is the ratio of the General Parity Index (GPI) in Turkey in 1973 to that in 1986?
Your answer should be very brief. 0.75. What is the ratio of the General Parity Index (GPI) of Europe(developing only) in 1973 to that in 1987?
Ensure brevity in your answer.  1.01. What is the ratio of the General Parity Index (GPI) of Benin in 1973 to that in 1987?
Keep it short and to the point. 1.11. What is the ratio of the General Parity Index (GPI) of Ireland in 1973 to that in 1987?
Provide a short and direct response. 0.99. What is the ratio of the General Parity Index (GPI) of Turkey in 1973 to that in 1987?
Your response must be concise. 0.74. What is the ratio of the General Parity Index (GPI) of Europe(developing only) in 1973 to that in 1999?
Your response must be concise. 1.02. What is the ratio of the General Parity Index (GPI) in Benin in 1973 to that in 1999?
Give a very brief answer. 0.97. What is the ratio of the General Parity Index (GPI) in Ireland in 1973 to that in 1999?
Your answer should be compact. 1.03. What is the ratio of the General Parity Index (GPI) of Turkey in 1973 to that in 1999?
Give a very brief answer. 0.6. What is the ratio of the General Parity Index (GPI) of Europe(developing only) in 1974 to that in 1977?
Your answer should be very brief. 1. What is the ratio of the General Parity Index (GPI) of Benin in 1974 to that in 1977?
Provide a short and direct response. 1.17. What is the ratio of the General Parity Index (GPI) of Ireland in 1974 to that in 1977?
Provide a succinct answer. 0.99. What is the ratio of the General Parity Index (GPI) in Turkey in 1974 to that in 1977?
Provide a succinct answer. 0.94. What is the ratio of the General Parity Index (GPI) of Benin in 1974 to that in 1986?
Offer a terse response. 1.14. What is the ratio of the General Parity Index (GPI) in Turkey in 1974 to that in 1986?
Your response must be concise. 0.79. What is the ratio of the General Parity Index (GPI) of Europe(developing only) in 1974 to that in 1987?
Keep it short and to the point. 1.02. What is the ratio of the General Parity Index (GPI) in Benin in 1974 to that in 1987?
Provide a short and direct response. 1.13. What is the ratio of the General Parity Index (GPI) of Ireland in 1974 to that in 1987?
Your answer should be very brief. 0.99. What is the ratio of the General Parity Index (GPI) in Turkey in 1974 to that in 1987?
Make the answer very short. 0.78. What is the ratio of the General Parity Index (GPI) in Europe(developing only) in 1974 to that in 1999?
Offer a terse response. 1.02. What is the ratio of the General Parity Index (GPI) of Benin in 1974 to that in 1999?
Ensure brevity in your answer.  0.99. What is the ratio of the General Parity Index (GPI) in Ireland in 1974 to that in 1999?
Your answer should be compact. 1.02. What is the ratio of the General Parity Index (GPI) in Turkey in 1974 to that in 1999?
Your answer should be very brief. 0.63. What is the ratio of the General Parity Index (GPI) of Europe(developing only) in 1977 to that in 1986?
Ensure brevity in your answer.  1.02. What is the ratio of the General Parity Index (GPI) of Benin in 1977 to that in 1986?
Your response must be concise. 0.98. What is the ratio of the General Parity Index (GPI) of Turkey in 1977 to that in 1986?
Give a very brief answer. 0.84. What is the ratio of the General Parity Index (GPI) in Europe(developing only) in 1977 to that in 1987?
Provide a succinct answer. 1.01. What is the ratio of the General Parity Index (GPI) in Benin in 1977 to that in 1987?
Give a very brief answer. 0.97. What is the ratio of the General Parity Index (GPI) of Ireland in 1977 to that in 1987?
Offer a very short reply. 1. What is the ratio of the General Parity Index (GPI) in Turkey in 1977 to that in 1987?
Give a very brief answer. 0.83. What is the ratio of the General Parity Index (GPI) in Europe(developing only) in 1977 to that in 1999?
Your answer should be very brief. 1.02. What is the ratio of the General Parity Index (GPI) of Benin in 1977 to that in 1999?
Ensure brevity in your answer.  0.84. What is the ratio of the General Parity Index (GPI) in Ireland in 1977 to that in 1999?
Ensure brevity in your answer.  1.04. What is the ratio of the General Parity Index (GPI) in Turkey in 1977 to that in 1999?
Offer a terse response. 0.67. What is the ratio of the General Parity Index (GPI) in Europe(developing only) in 1986 to that in 1987?
Your answer should be compact. 1. What is the ratio of the General Parity Index (GPI) in Benin in 1986 to that in 1987?
Your response must be concise. 0.99. What is the ratio of the General Parity Index (GPI) of Turkey in 1986 to that in 1987?
Provide a succinct answer. 0.99. What is the ratio of the General Parity Index (GPI) of Europe(developing only) in 1986 to that in 1999?
Provide a succinct answer. 1. What is the ratio of the General Parity Index (GPI) of Benin in 1986 to that in 1999?
Provide a succinct answer. 0.86. What is the ratio of the General Parity Index (GPI) in Ireland in 1986 to that in 1999?
Offer a very short reply. 1.04. What is the ratio of the General Parity Index (GPI) of Turkey in 1986 to that in 1999?
Your answer should be compact. 0.8. What is the ratio of the General Parity Index (GPI) of Benin in 1987 to that in 1999?
Your answer should be very brief. 0.87. What is the ratio of the General Parity Index (GPI) of Ireland in 1987 to that in 1999?
Provide a short and direct response. 1.04. What is the ratio of the General Parity Index (GPI) of Turkey in 1987 to that in 1999?
Ensure brevity in your answer.  0.81. What is the difference between the highest and the second highest General Parity Index (GPI) in Europe(developing only)?
Provide a short and direct response. 0. What is the difference between the highest and the second highest General Parity Index (GPI) in Benin?
Your response must be concise. 0.01. What is the difference between the highest and the second highest General Parity Index (GPI) in Ireland?
Give a very brief answer. 0. What is the difference between the highest and the second highest General Parity Index (GPI) of Turkey?
Ensure brevity in your answer.  0.13. What is the difference between the highest and the lowest General Parity Index (GPI) of Europe(developing only)?
Offer a very short reply. 0.02. What is the difference between the highest and the lowest General Parity Index (GPI) of Benin?
Provide a succinct answer. 0.07. What is the difference between the highest and the lowest General Parity Index (GPI) in Ireland?
Provide a short and direct response. 0.04. What is the difference between the highest and the lowest General Parity Index (GPI) in Turkey?
Give a very brief answer. 0.3. 